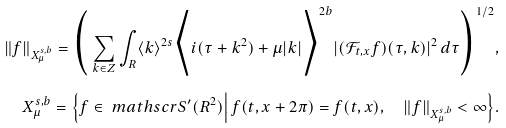Convert formula to latex. <formula><loc_0><loc_0><loc_500><loc_500>\| f \| _ { X _ { \mu } ^ { s , b } } = \Big ( \sum _ { k \in Z } \int _ { R } \langle k \rangle ^ { 2 s } \Big \langle i ( \tau + k ^ { 2 } ) + \mu | k | \Big \rangle ^ { 2 b } | ( \mathcal { F } _ { t , x } f ) ( \tau , k ) | ^ { 2 } \, d \tau \Big ) ^ { 1 / 2 } , \\ X _ { \mu } ^ { s , b } = \Big \{ f \in \ m a t h s c r { S } ^ { \prime } ( R ^ { 2 } ) \Big | \ f ( t , x + 2 \pi ) = f ( t , x ) , \quad \| f \| _ { X _ { \mu } ^ { s , b } } < \infty \Big \} .</formula> 